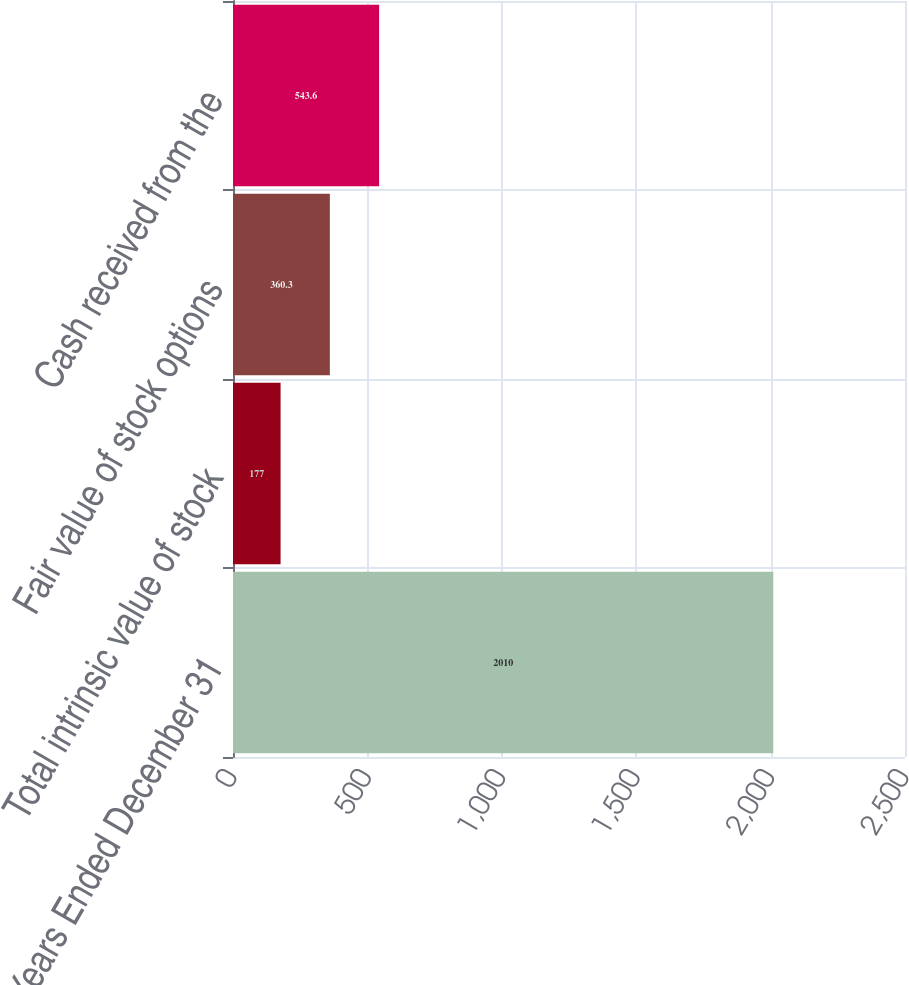<chart> <loc_0><loc_0><loc_500><loc_500><bar_chart><fcel>Years Ended December 31<fcel>Total intrinsic value of stock<fcel>Fair value of stock options<fcel>Cash received from the<nl><fcel>2010<fcel>177<fcel>360.3<fcel>543.6<nl></chart> 